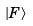<formula> <loc_0><loc_0><loc_500><loc_500>| F \rangle</formula> 